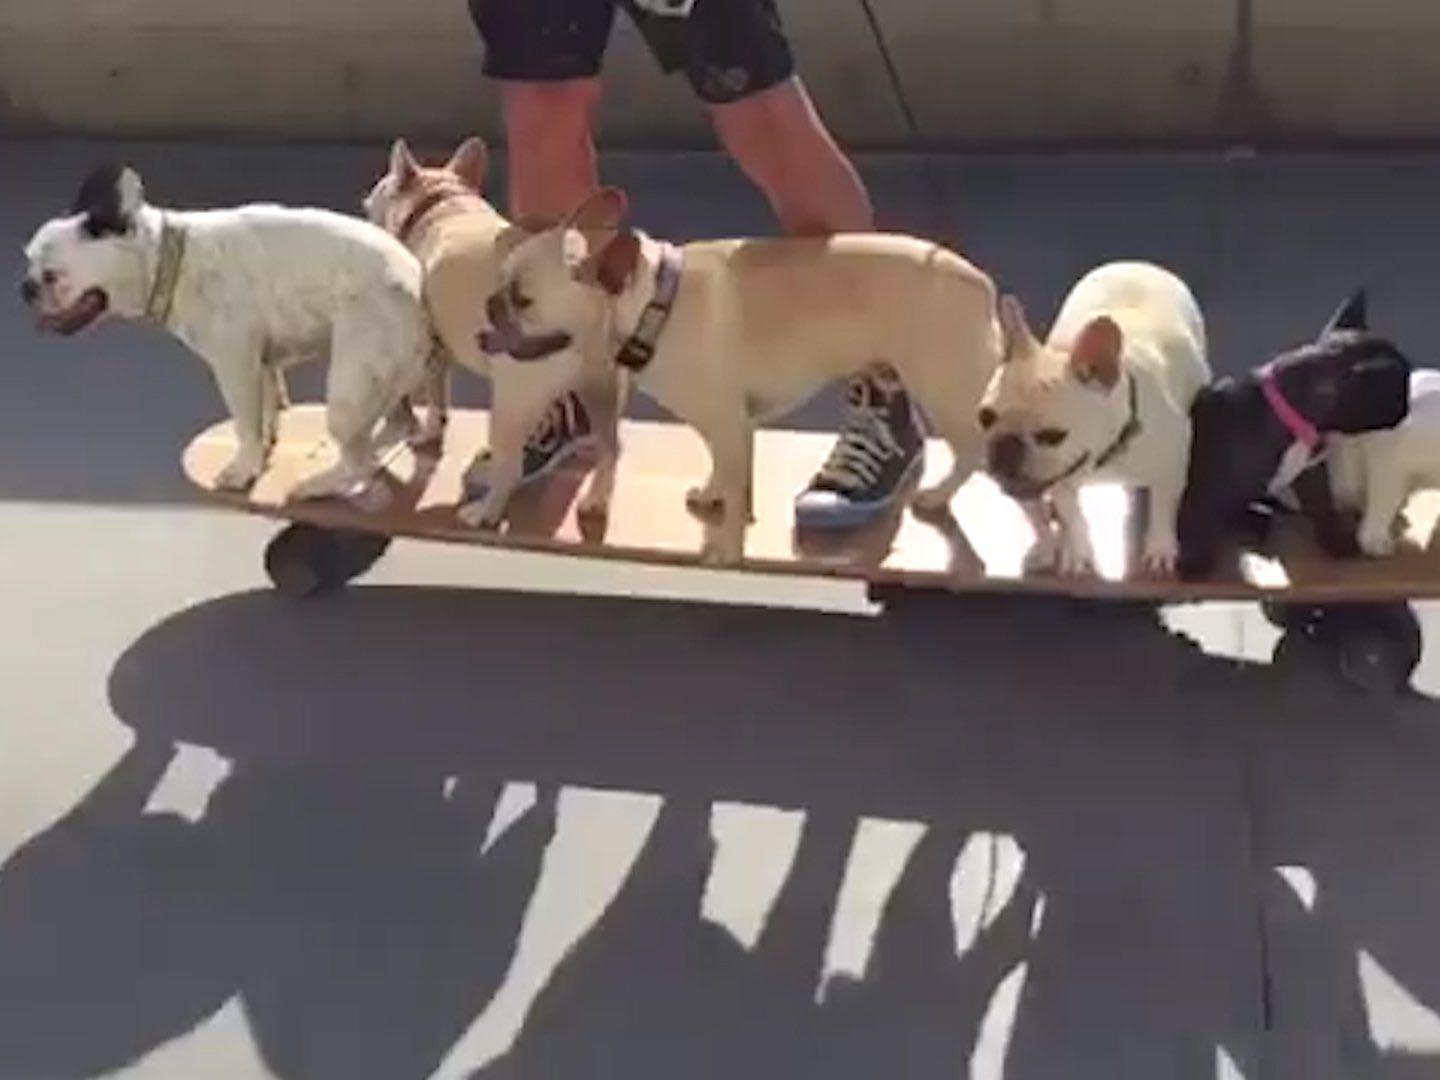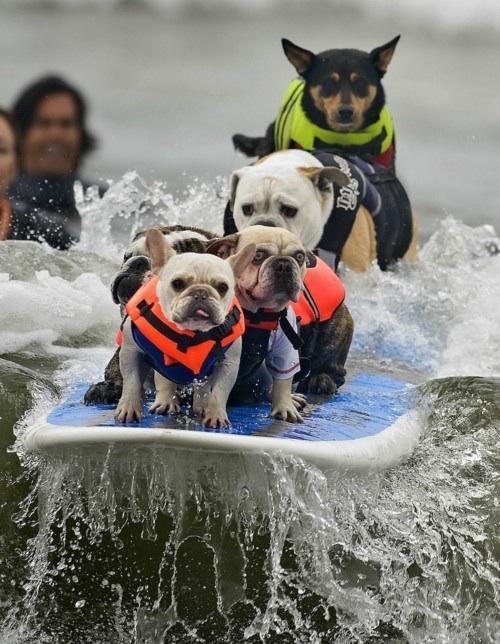The first image is the image on the left, the second image is the image on the right. Assess this claim about the two images: "An image shows exactly one dog, which is sitting.". Correct or not? Answer yes or no. No. 